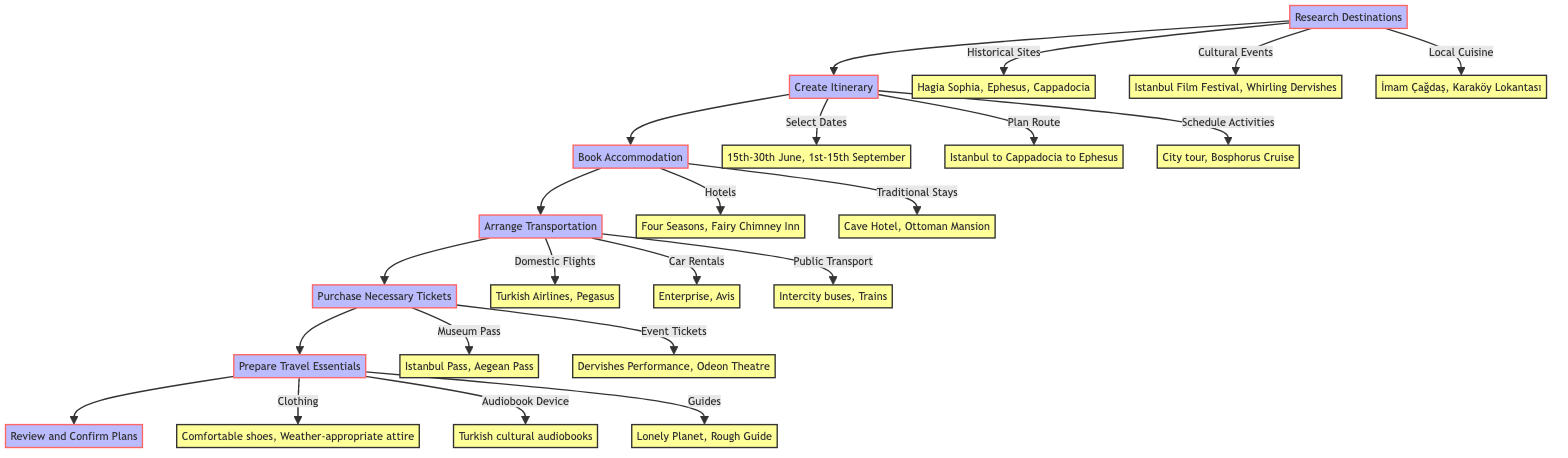What is the first step in the flowchart? The first step is "Research Destinations," which is the starting point of the flowchart leading to the creation of an itinerary.
Answer: Research Destinations How many sub-elements appear under 'Create Itinerary'? The 'Create Itinerary' element has three sub-elements: 'Select Travel Dates,' 'Plan Route,' and 'Schedule Activities.' Thus, there are 3 sub-elements.
Answer: 3 What are the two types of accommodation bookings listed? The accommodations can be categorized into 'Hotel Reservation' and 'Traditional Stays,' which directly stem from the 'Book Accommodation' node.
Answer: Hotel Reservation and Traditional Stays What activities are scheduled under 'Prepare Travel Essentials'? The activities listed under 'Prepare Travel Essentials' include 'Pack Appropriate Clothing,' 'Hi-Fi Audiobook Device,' and 'Guidebooks and Maps,' contributing to travel readiness.
Answer: Pack Appropriate Clothing, Hi-Fi Audiobook Device, and Guidebooks and Maps Which sub-element falls under 'Arrange Transportation' and involves public transit? The sub-element concerning public transit is 'Public Transport,' which represents one of the transportation methods outlined in this section of the flowchart.
Answer: Public Transport What is the last step in the planning process according to the diagram? The final step in the diagram is 'Review and Confirm Plans,' which serves as the culminating action to finalize all travel arrangements.
Answer: Review and Confirm Plans How are 'Domestic Flights' categorized in the flowchart? 'Domestic Flights' is classified under the 'Arrange Transportation' element, indicating it's one of the methods for moving between destinations.
Answer: Domestic Flights List one example of a cultural event found in the research phase. One example of a cultural event mentioned during the 'Research Destinations' phase is the 'Istanbul International Film Festival.'
Answer: Istanbul International Film Festival Which node leads to the 'Purchase Necessary Tickets' step? The step that directly leads to 'Purchase Necessary Tickets' is 'Arrange Transportation,' indicating the sequence in the planning process before purchasing tickets.
Answer: Arrange Transportation 